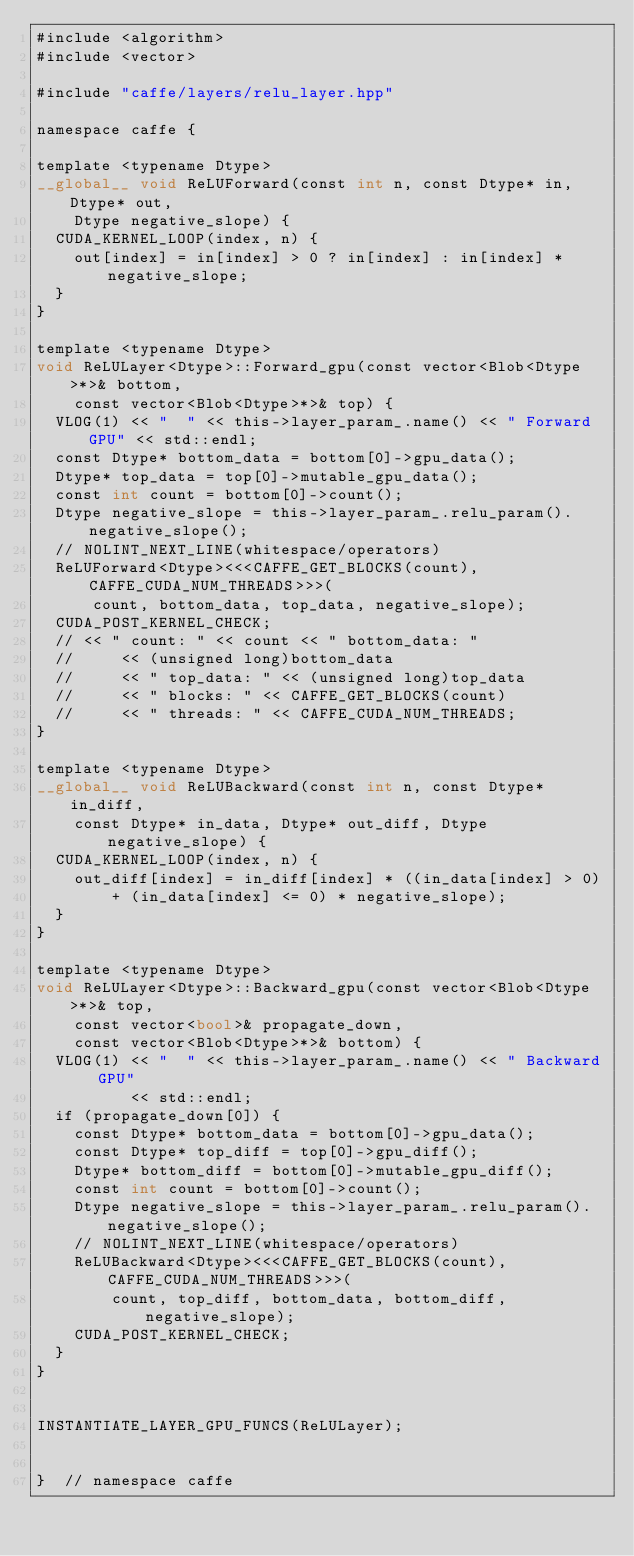Convert code to text. <code><loc_0><loc_0><loc_500><loc_500><_Cuda_>#include <algorithm>
#include <vector>

#include "caffe/layers/relu_layer.hpp"

namespace caffe {

template <typename Dtype>
__global__ void ReLUForward(const int n, const Dtype* in, Dtype* out,
    Dtype negative_slope) {
  CUDA_KERNEL_LOOP(index, n) {
    out[index] = in[index] > 0 ? in[index] : in[index] * negative_slope;
  }
}

template <typename Dtype>
void ReLULayer<Dtype>::Forward_gpu(const vector<Blob<Dtype>*>& bottom,
    const vector<Blob<Dtype>*>& top) {
  VLOG(1) << "  " << this->layer_param_.name() << " Forward GPU" << std::endl;
  const Dtype* bottom_data = bottom[0]->gpu_data();
  Dtype* top_data = top[0]->mutable_gpu_data();
  const int count = bottom[0]->count();
  Dtype negative_slope = this->layer_param_.relu_param().negative_slope();
  // NOLINT_NEXT_LINE(whitespace/operators)
  ReLUForward<Dtype><<<CAFFE_GET_BLOCKS(count), CAFFE_CUDA_NUM_THREADS>>>(
      count, bottom_data, top_data, negative_slope);
  CUDA_POST_KERNEL_CHECK;
  // << " count: " << count << " bottom_data: "
  //     << (unsigned long)bottom_data
  //     << " top_data: " << (unsigned long)top_data
  //     << " blocks: " << CAFFE_GET_BLOCKS(count)
  //     << " threads: " << CAFFE_CUDA_NUM_THREADS;
}

template <typename Dtype>
__global__ void ReLUBackward(const int n, const Dtype* in_diff,
    const Dtype* in_data, Dtype* out_diff, Dtype negative_slope) {
  CUDA_KERNEL_LOOP(index, n) {
    out_diff[index] = in_diff[index] * ((in_data[index] > 0)
        + (in_data[index] <= 0) * negative_slope);
  }
}

template <typename Dtype>
void ReLULayer<Dtype>::Backward_gpu(const vector<Blob<Dtype>*>& top,
    const vector<bool>& propagate_down,
    const vector<Blob<Dtype>*>& bottom) {
  VLOG(1) << "  " << this->layer_param_.name() << " Backward GPU"
          << std::endl;
  if (propagate_down[0]) {
    const Dtype* bottom_data = bottom[0]->gpu_data();
    const Dtype* top_diff = top[0]->gpu_diff();
    Dtype* bottom_diff = bottom[0]->mutable_gpu_diff();
    const int count = bottom[0]->count();
    Dtype negative_slope = this->layer_param_.relu_param().negative_slope();
    // NOLINT_NEXT_LINE(whitespace/operators)
    ReLUBackward<Dtype><<<CAFFE_GET_BLOCKS(count), CAFFE_CUDA_NUM_THREADS>>>(
        count, top_diff, bottom_data, bottom_diff, negative_slope);
    CUDA_POST_KERNEL_CHECK;
  }
}


INSTANTIATE_LAYER_GPU_FUNCS(ReLULayer);


}  // namespace caffe
</code> 